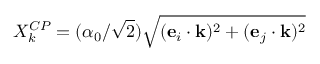<formula> <loc_0><loc_0><loc_500><loc_500>X _ { k } ^ { C P } = ( \alpha _ { 0 } / \sqrt { 2 } ) \sqrt { ( e _ { i } \cdot k ) ^ { 2 } + ( e _ { j } \cdot k ) ^ { 2 } }</formula> 